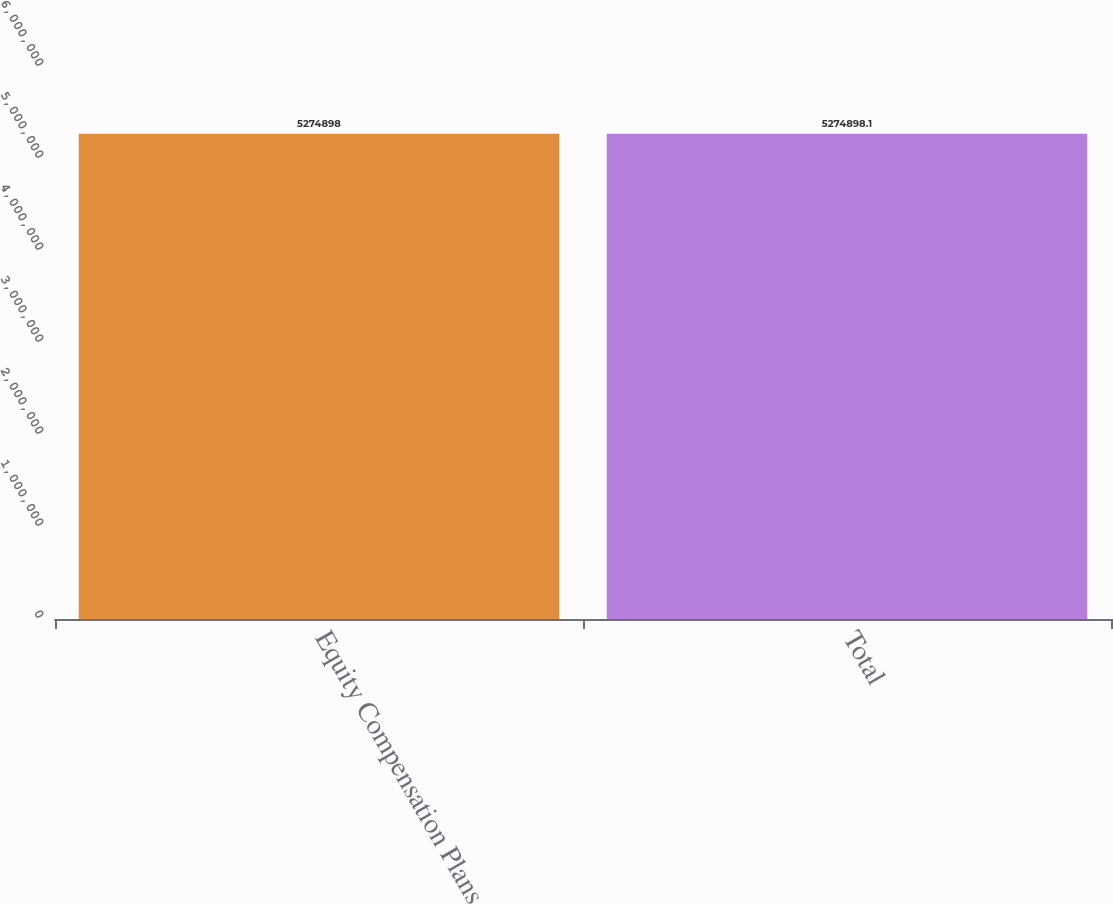Convert chart to OTSL. <chart><loc_0><loc_0><loc_500><loc_500><bar_chart><fcel>Equity Compensation Plans<fcel>Total<nl><fcel>5.2749e+06<fcel>5.2749e+06<nl></chart> 